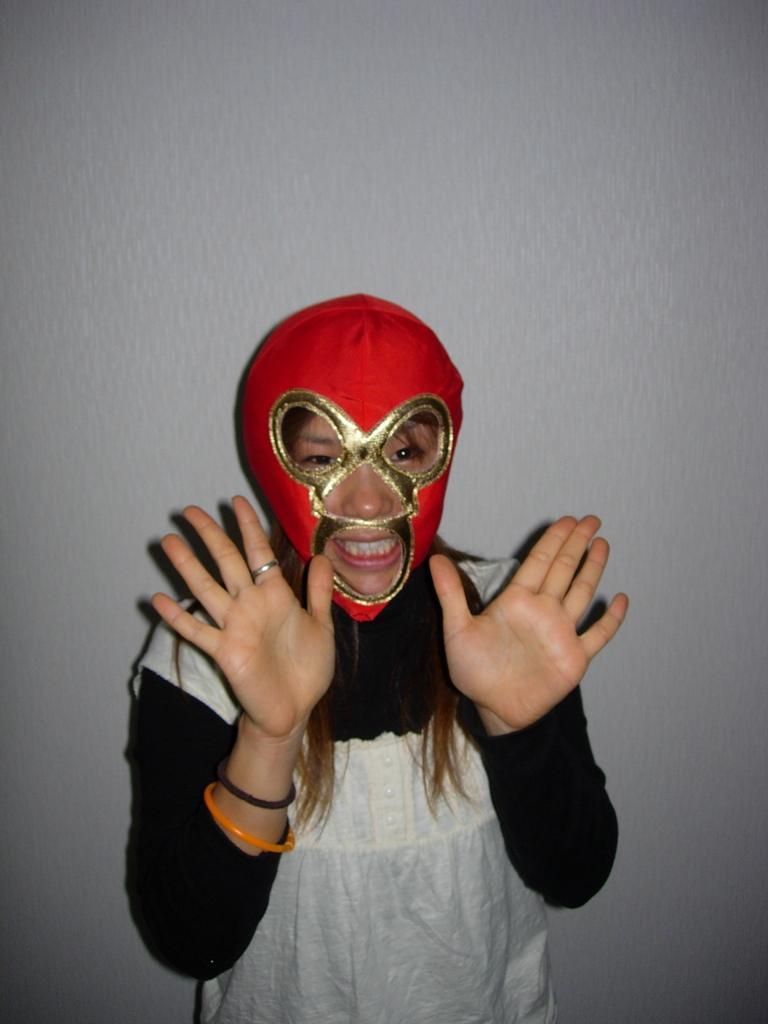How would you summarize this image in a sentence or two? In this image, we can see a woman standing and she is wearing a mask on the head, in the background we can see the wall. 